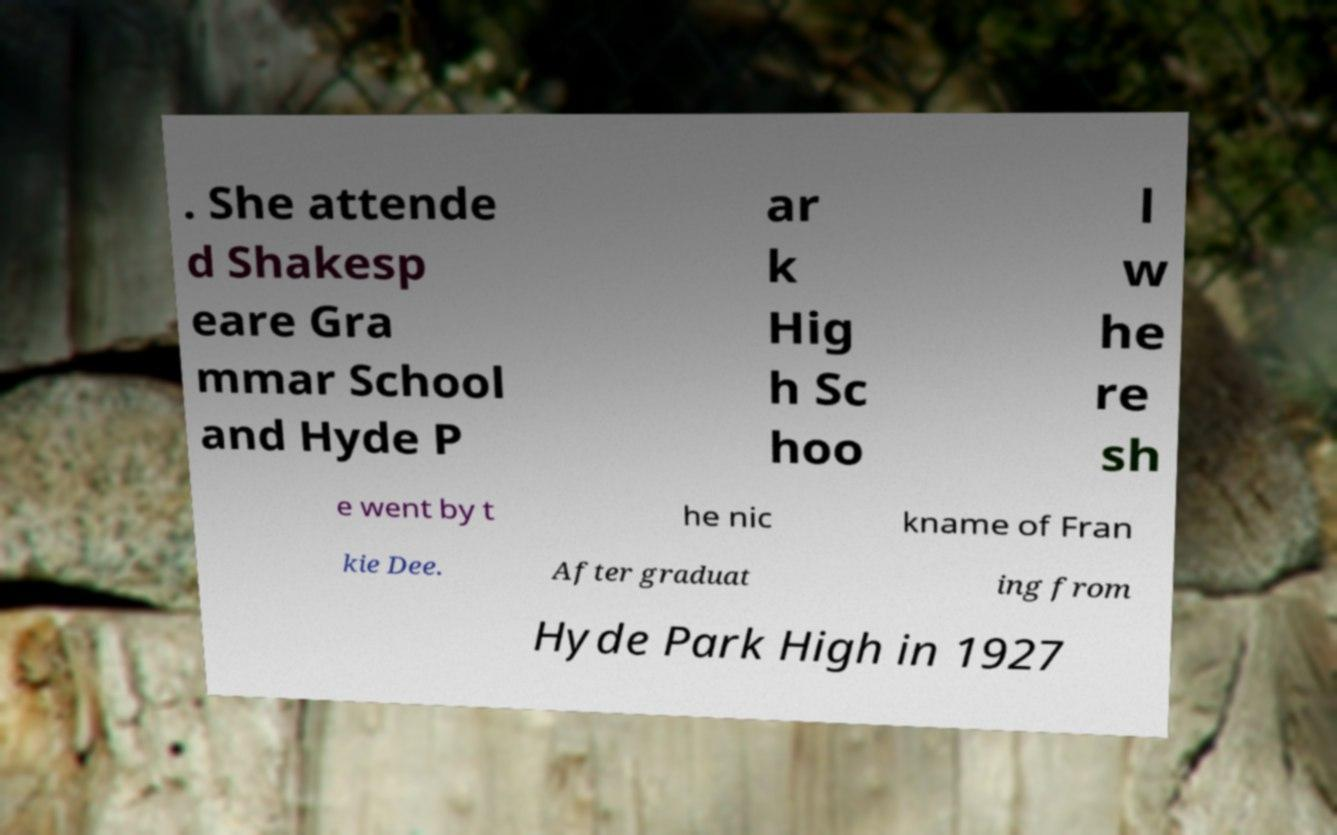Could you extract and type out the text from this image? . She attende d Shakesp eare Gra mmar School and Hyde P ar k Hig h Sc hoo l w he re sh e went by t he nic kname of Fran kie Dee. After graduat ing from Hyde Park High in 1927 